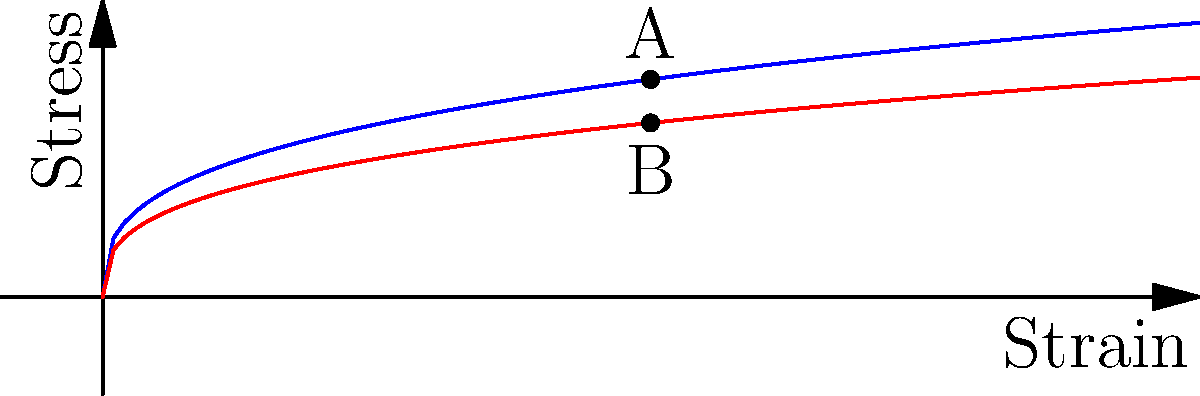In the stress-strain curve shown, two materials are represented: a standard biomaterial (blue curve) and a modified version (red curve). Both follow a power-law relationship where stress $\sigma = k\epsilon^{1/3}$, with $\epsilon$ being strain and $k$ a constant. If point A represents the stress at a strain of 4 for the standard material, what is the ratio of stress at point B to point A? To solve this problem, we'll follow these steps:

1) The blue curve represents the standard material, where $\sigma = k\epsilon^{1/3}$.
2) The red curve represents the modified material, where $\sigma = 0.8k\epsilon^{1/3}$.
3) At point A (standard material), the strain $\epsilon = 4$:
   $\sigma_A = k(4)^{1/3} = 1.587k$
4) At point B (modified material), the strain is also 4:
   $\sigma_B = 0.8k(4)^{1/3} = 0.8 \times 1.587k = 1.270k$
5) The ratio of stress at B to A is:
   $\frac{\sigma_B}{\sigma_A} = \frac{1.270k}{1.587k} = 0.8$

This ratio is independent of $k$, showing that the modified material has 80% of the stress response of the standard material at any given strain.
Answer: 0.8 